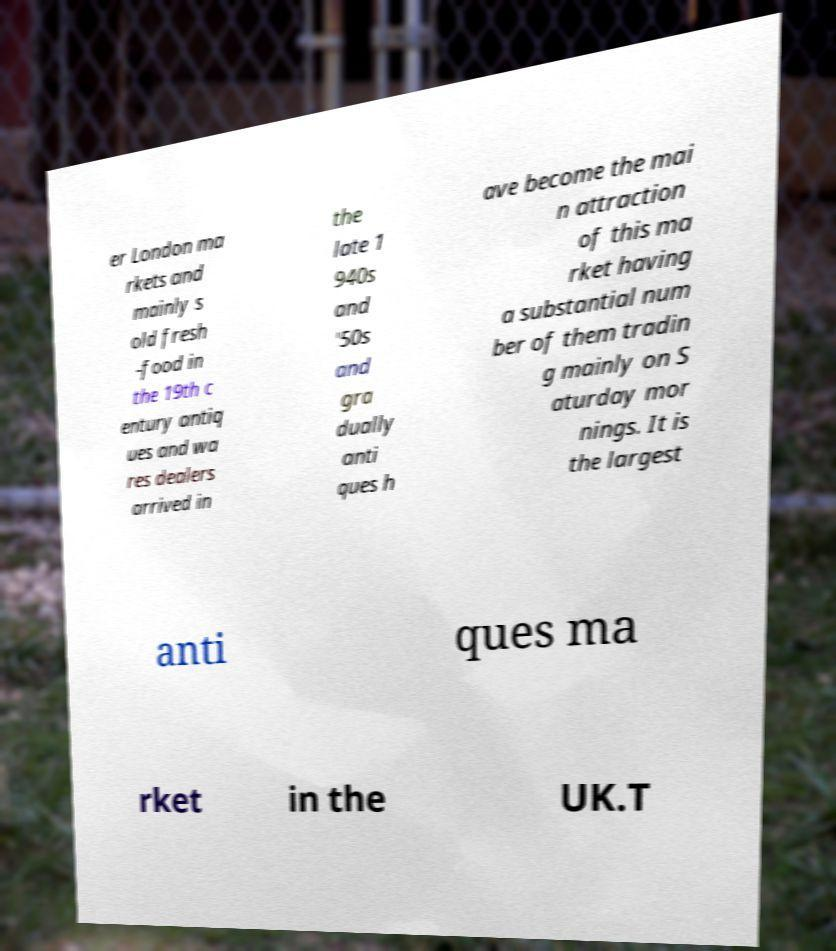There's text embedded in this image that I need extracted. Can you transcribe it verbatim? er London ma rkets and mainly s old fresh -food in the 19th c entury antiq ues and wa res dealers arrived in the late 1 940s and '50s and gra dually anti ques h ave become the mai n attraction of this ma rket having a substantial num ber of them tradin g mainly on S aturday mor nings. It is the largest anti ques ma rket in the UK.T 